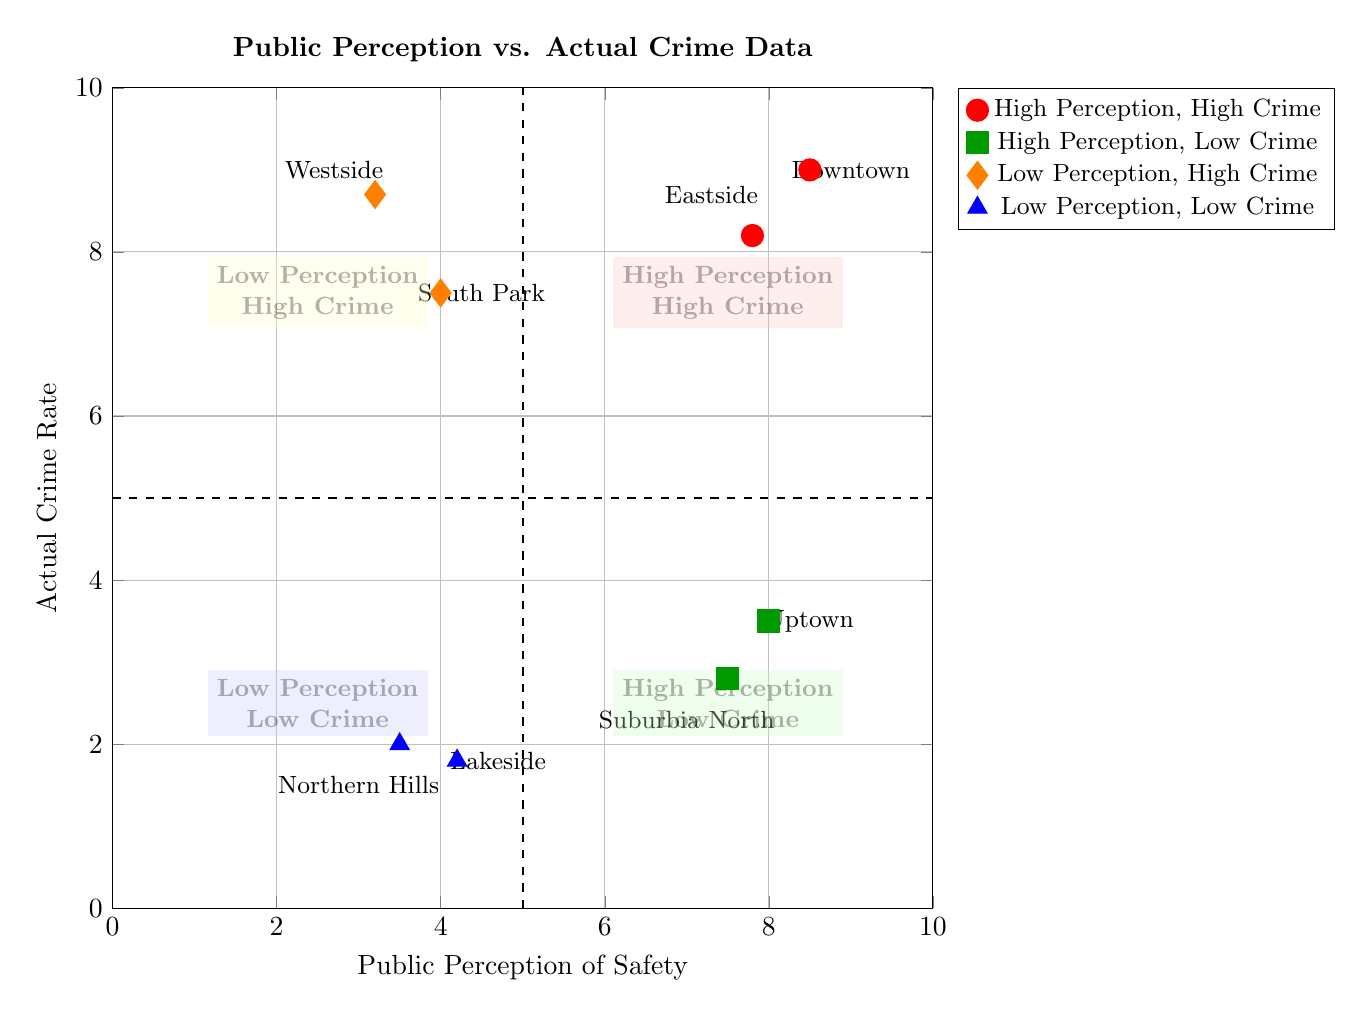What's the actual crime rate in Uptown? The diagram shows a point for Uptown with an actual crime rate value of 3.5 on the y-axis.
Answer: 3.5 Which neighborhood has the highest public perception score? The point with the highest public perception score appears to be Downtown, which is at 8.5 on the x-axis.
Answer: Downtown How many neighborhoods fall into the "Low Perception, High Crime" quadrant? The quadrant has two neighborhoods marked: Westside and South Park. Thus, there are two neighborhoods.
Answer: 2 What's the public perception score of Northern Hills? At the Northern Hills point on the diagram, the public perception score indicated on the x-axis is 3.5.
Answer: 3.5 Which quadrant has neighborhoods with high crime rates despite a low public perception? There is a quadrant labeled "Low Perception, High Crime," which includes neighborhoods with high crime rates but low public perception.
Answer: Low Perception, High Crime In which quadrant does Suburbia North appear? The coordinates of Suburbia North place it within the quadrant labeled "High Perception, Low Crime," as its public perception is 7.5 while its crime rate is 2.8.
Answer: High Perception, Low Crime What is the public perception score of South Park? The diagram indicates that South Park has a public perception score of 4.0 located on the x-axis.
Answer: 4.0 How is the actual crime rate of Downtown compared to Eastside? Downtown's crime rate is 9.0, which is higher than Eastside's crime rate of 8.2, indicating that Downtown has a comparatively higher crime rate.
Answer: Higher Is there any neighborhood with a low public perception but a low crime rate? Yes, the quadrant "Low Perception, Low Crime" includes neighborhoods like Northern Hills and Lakeside, which have low scores in both metrics.
Answer: Yes 